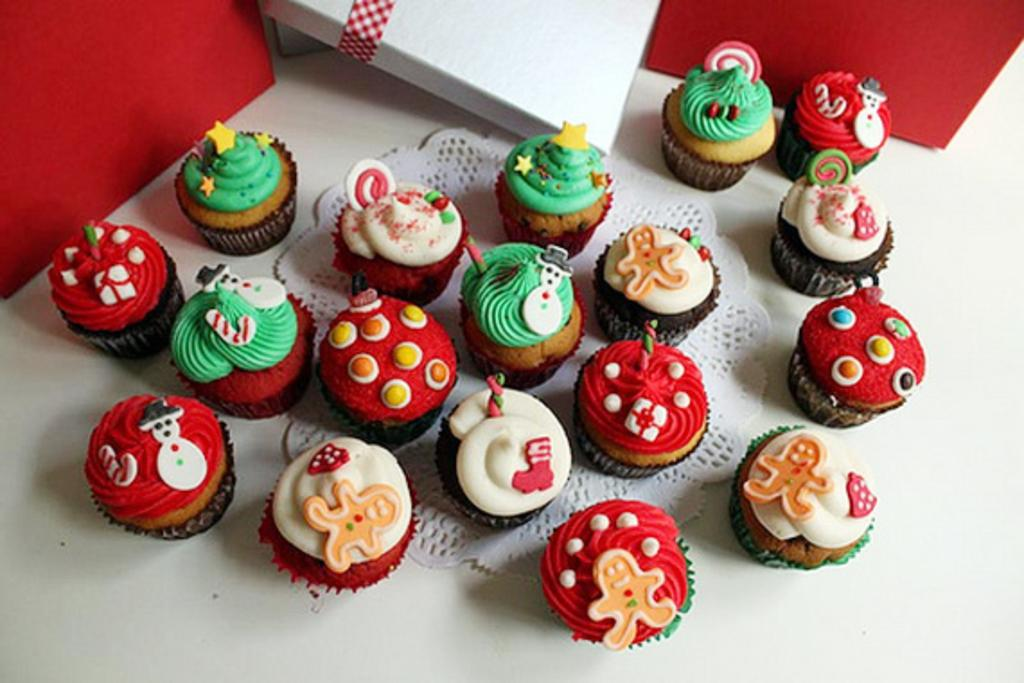What type of dessert is present on the table in the image? There are many cupcakes on the table. What other items can be seen on the table? There are cotton boxes in the image. What type of trade is being conducted in the image? There is no indication of any trade being conducted in the image; it primarily features cupcakes and cotton boxes. 